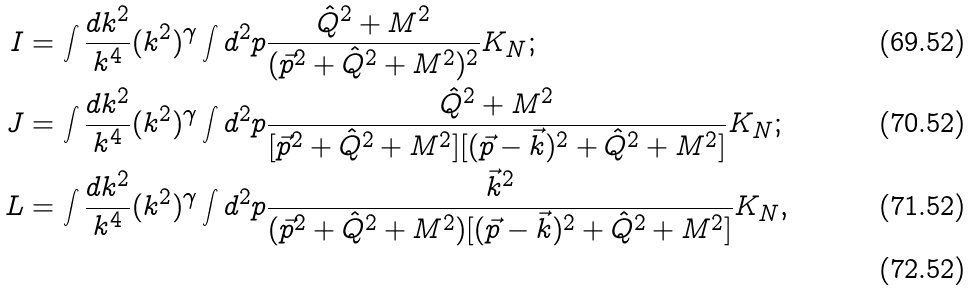<formula> <loc_0><loc_0><loc_500><loc_500>I & = \int \frac { d k ^ { 2 } } { k ^ { 4 } } ( k ^ { 2 } ) ^ { \gamma } \int d ^ { 2 } p \frac { \hat { Q } ^ { 2 } + M ^ { 2 } } { ( \vec { p } ^ { 2 } + \hat { Q } ^ { 2 } + M ^ { 2 } ) ^ { 2 } } K _ { N } ; \\ J & = \int \frac { d k ^ { 2 } } { k ^ { 4 } } ( k ^ { 2 } ) ^ { \gamma } \int d ^ { 2 } p \frac { \hat { Q } ^ { 2 } + M ^ { 2 } } { [ \vec { p } ^ { 2 } + \hat { Q } ^ { 2 } + M ^ { 2 } ] [ ( \vec { p } - \vec { k } ) ^ { 2 } + \hat { Q } ^ { 2 } + M ^ { 2 } ] } K _ { N } ; \\ L & = \int \frac { d k ^ { 2 } } { k ^ { 4 } } ( k ^ { 2 } ) ^ { \gamma } \int d ^ { 2 } p \frac { \vec { k } ^ { 2 } } { ( \vec { p } ^ { 2 } + \hat { Q } ^ { 2 } + M ^ { 2 } ) [ ( \vec { p } - \vec { k } ) ^ { 2 } + \hat { Q } ^ { 2 } + M ^ { 2 } ] } K _ { N } , \\</formula> 